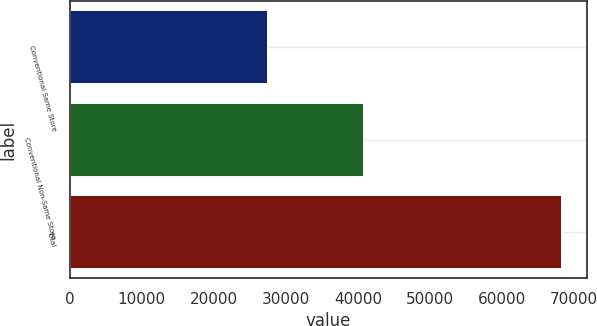Convert chart. <chart><loc_0><loc_0><loc_500><loc_500><bar_chart><fcel>Conventional Same Store<fcel>Conventional Non-Same Store<fcel>Total<nl><fcel>27530<fcel>40820<fcel>68350<nl></chart> 